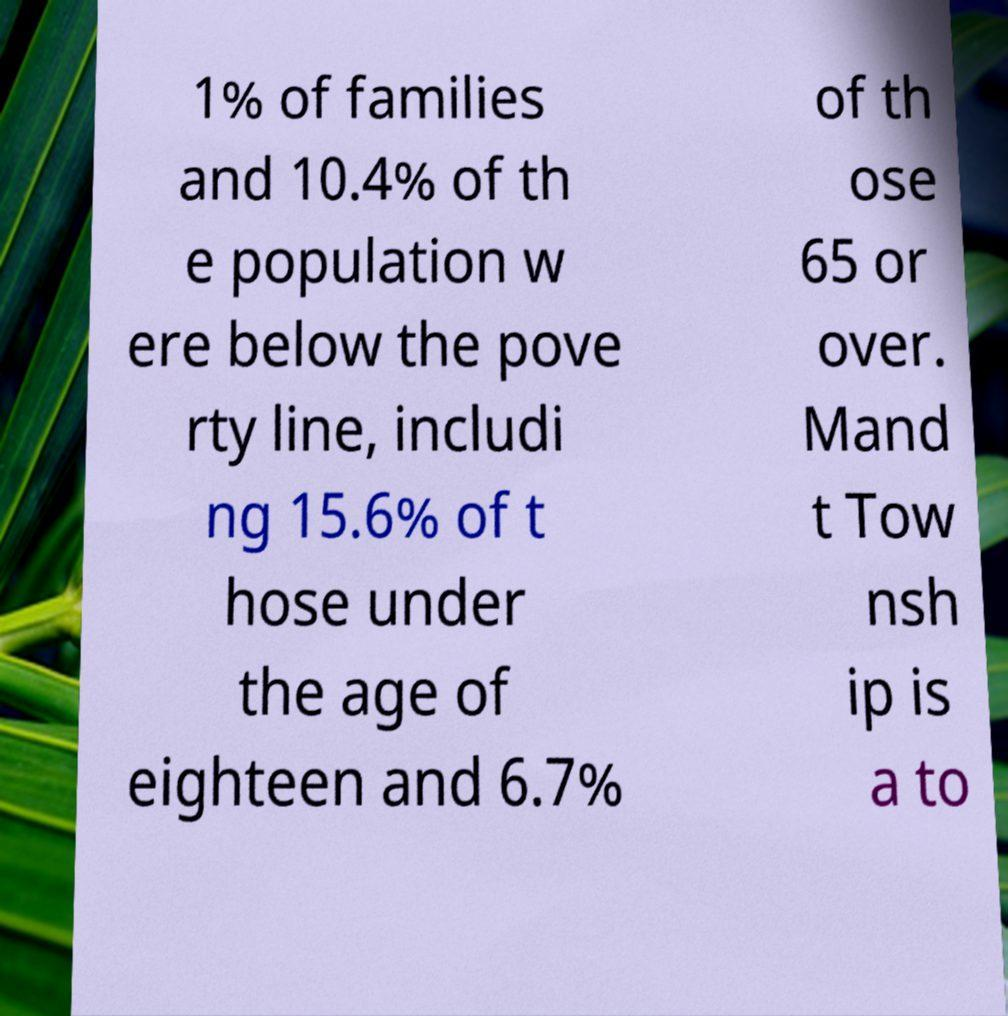I need the written content from this picture converted into text. Can you do that? 1% of families and 10.4% of th e population w ere below the pove rty line, includi ng 15.6% of t hose under the age of eighteen and 6.7% of th ose 65 or over. Mand t Tow nsh ip is a to 